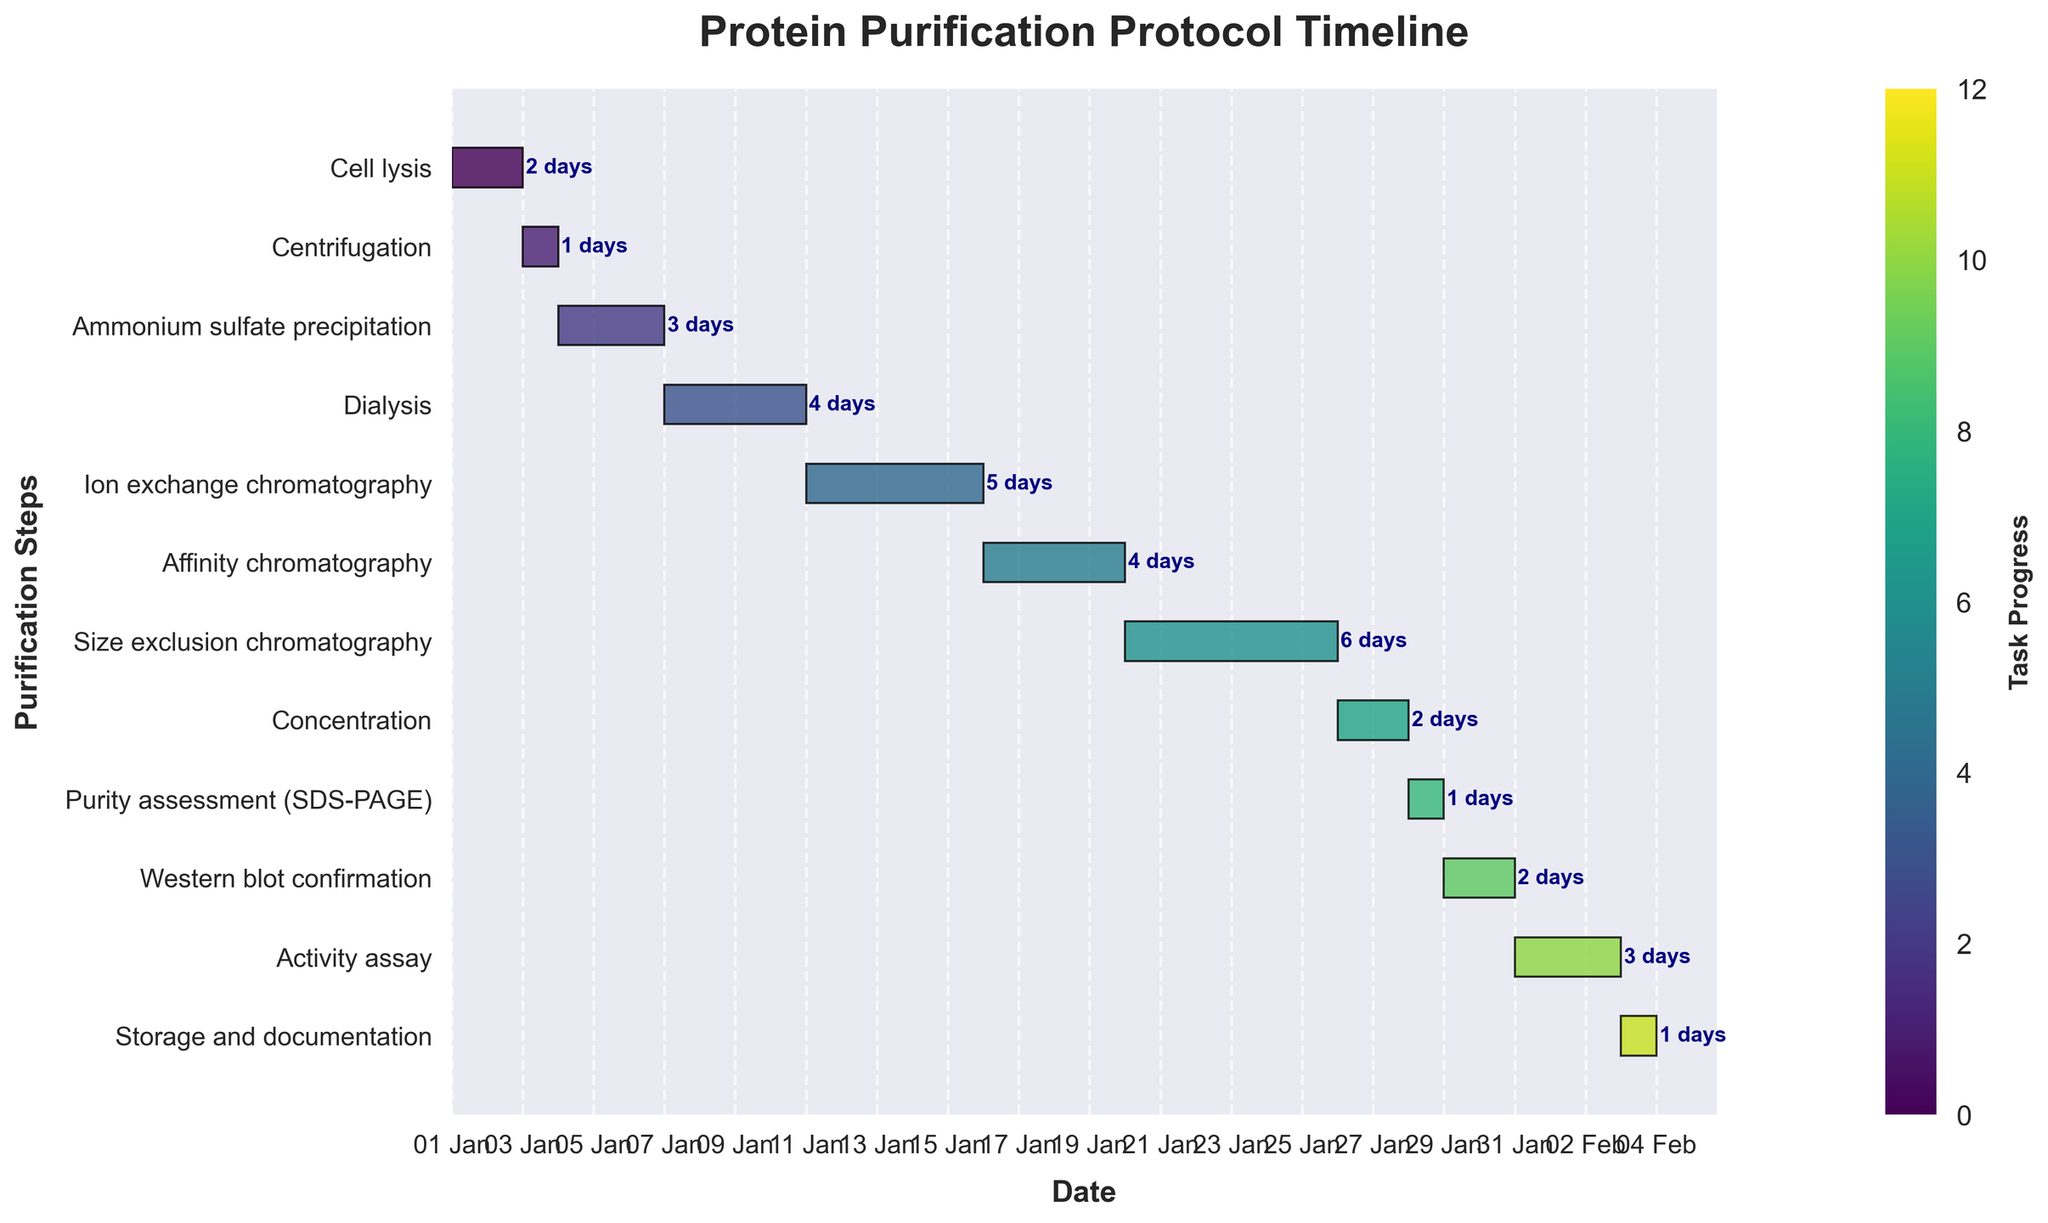What is the duration of the Cell lysis step? The Cell lysis step starts at day 0 and lasts for 2 days as indicated directly in the figure.
Answer: 2 days How long is the entire protein purification process from start to end? The process starts at day 0 (Cell lysis) and ends on day 34 (Storage and documentation). Therefore, it spans from day 0 to day 34.
Answer: 34 days Which purification step takes the longest time? By observing the chart, the longest step is Size exclusion chromatography, which lasts for 6 days.
Answer: Size exclusion chromatography How many days in total are spent on chromatography steps? Ion exchange chromatography (5 days) + Affinity chromatography (4 days) + Size exclusion chromatography (6 days) = 15 days total.
Answer: 15 days Compare the durations of Affinity chromatography and Activity assay. Which one is longer and by how many days? Affinity chromatography lasts 4 days, while Activity assay lasts 3 days. Therefore, Affinity chromatography is 1 day longer.
Answer: Affinity chromatography, 1 day longer When does the Dialysis step end and what step follows immediately after? The Dialysis step starts on day 6 and lasts for 4 days, so it ends on day 10. The next step is Ion exchange chromatography.
Answer: Day 10; Ion exchange chromatography What steps are scheduled to occur simultaneously after the first week? After the first week (from Day 7 onwards), no steps are scheduled to occur simultaneously as each step follows sequentially after the previous one.
Answer: None What is the interval between the end of Centrifugation and the start of Dialysis? Centrifugation ends on day 3 and Dialysis starts on day 6. The interval between them is 3 days.
Answer: 3 days How does the duration of Western blot confirmation compare to Purity assessment (SDS-PAGE)? Western blot confirmation lasts for 2 days, while Purity assessment (SDS-PAGE) lasts for only 1 day. Thus, Western blot confirmation lasts 1 day longer.
Answer: Western blot confirmation lasts 1 day longer Would the process be shorter if we remove the Affinity chromatography step? By how many days? The Affinity chromatography step lasts for 4 days. Removing it would reduce the total process duration from 34 days to 30 days.
Answer: 4 days shorter 